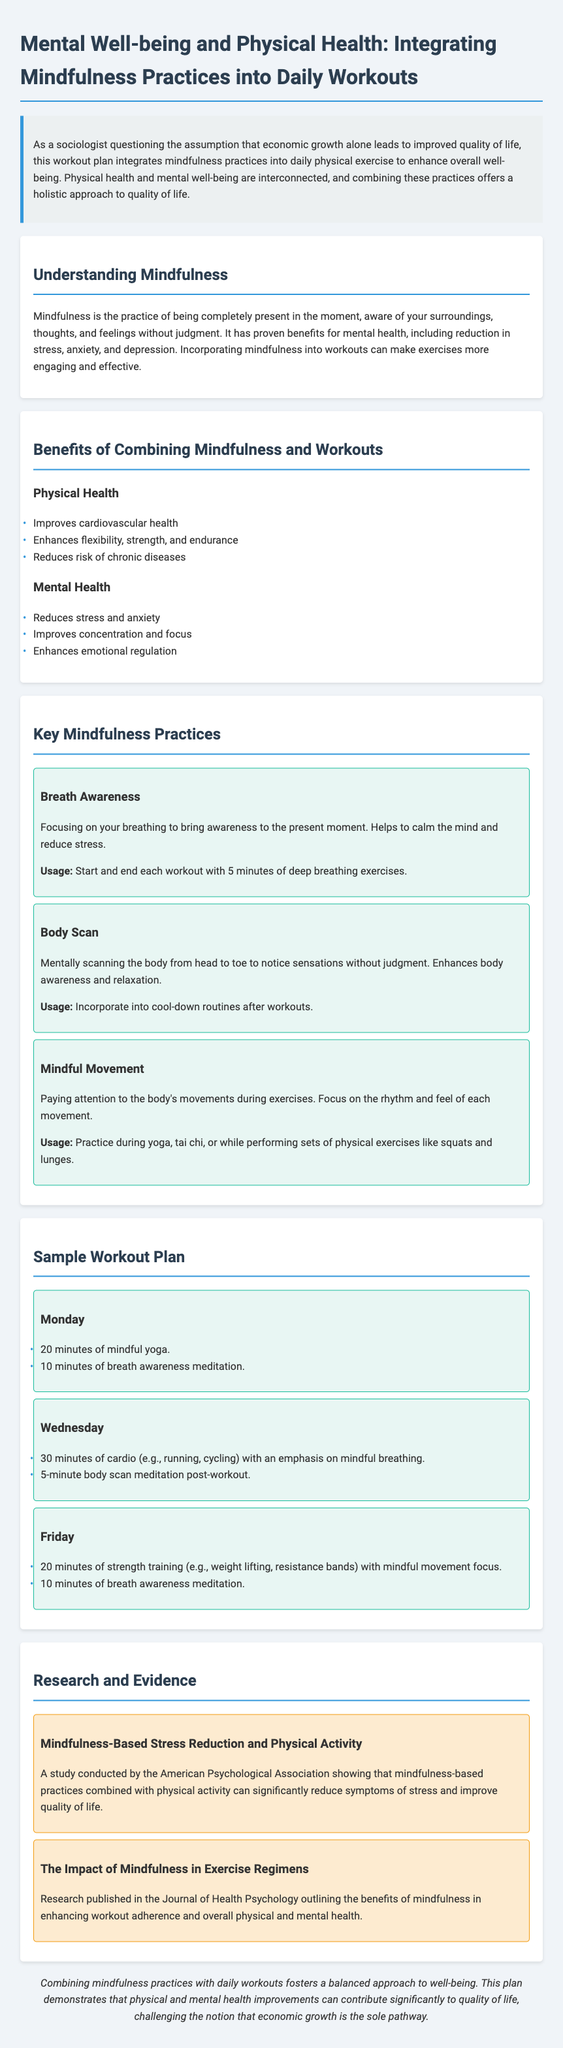what is the title of the document? The title is prominently displayed at the top of the document and summarizes its focus on mental well-being and physical health.
Answer: Mental Well-being and Physical Health: Integrating Mindfulness Practices into Daily Workouts what is one benefit of combining mindfulness and workouts for physical health? The document lists several benefits under physical health, specifically highlighting one for readers.
Answer: Improves cardiovascular health which day includes mindful yoga in the sample workout plan? The specific day for mindful yoga is detailed in the sample workout section, indicating its placement within the week.
Answer: Monday what practice is suggested for calmness before and after workouts? This practice is emphasized in the key mindfulness practices section for its calming effects.
Answer: Breath Awareness how many minutes of strength training are suggested on Friday? The document specifies the duration of strength training exercises on a particular day in the sample workout plan.
Answer: 20 minutes what impact does mindfulness-based stress reduction have according to the study? The study highlights the results of combining mindfulness with physical activity in enhancing well-being for the reader to note.
Answer: Significantly reduce symptoms of stress which practice emphasizes rhythm and feel of movements? The document names specific practices and highlights which one focuses on movement sensations particularly.
Answer: Mindful Movement 